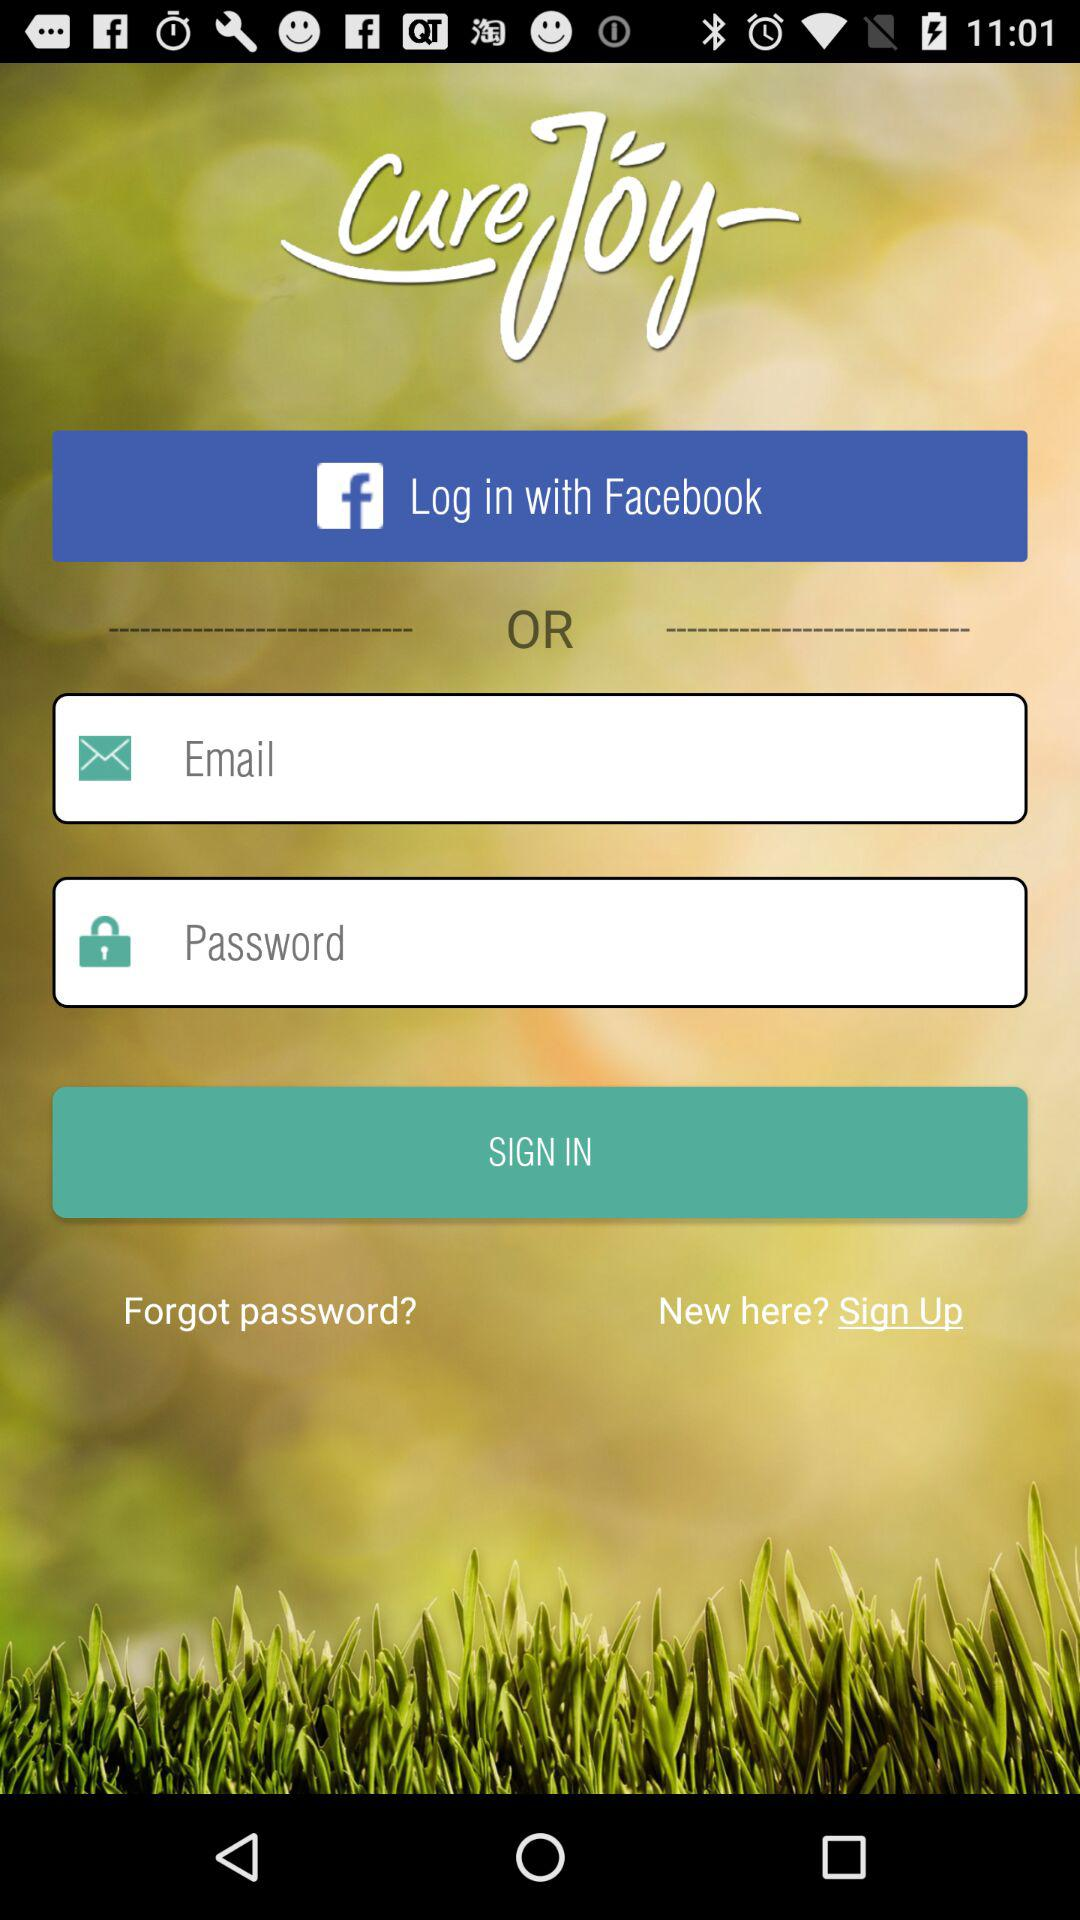What is the name of the application? The name of the application is "CureJoy". 